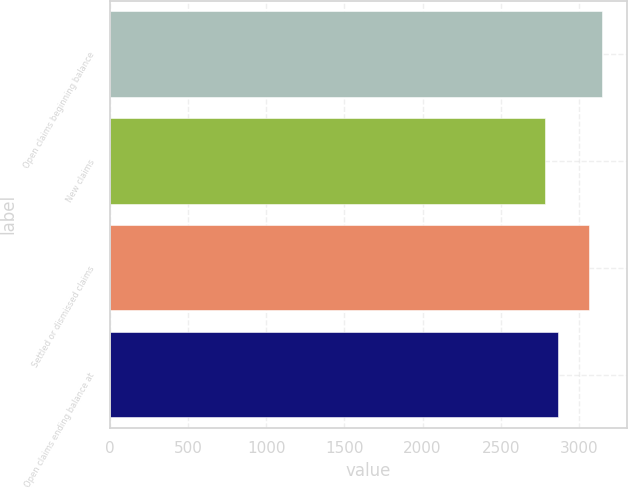Convert chart to OTSL. <chart><loc_0><loc_0><loc_500><loc_500><bar_chart><fcel>Open claims beginning balance<fcel>New claims<fcel>Settled or dismissed claims<fcel>Open claims ending balance at<nl><fcel>3151<fcel>2781<fcel>3063<fcel>2869<nl></chart> 